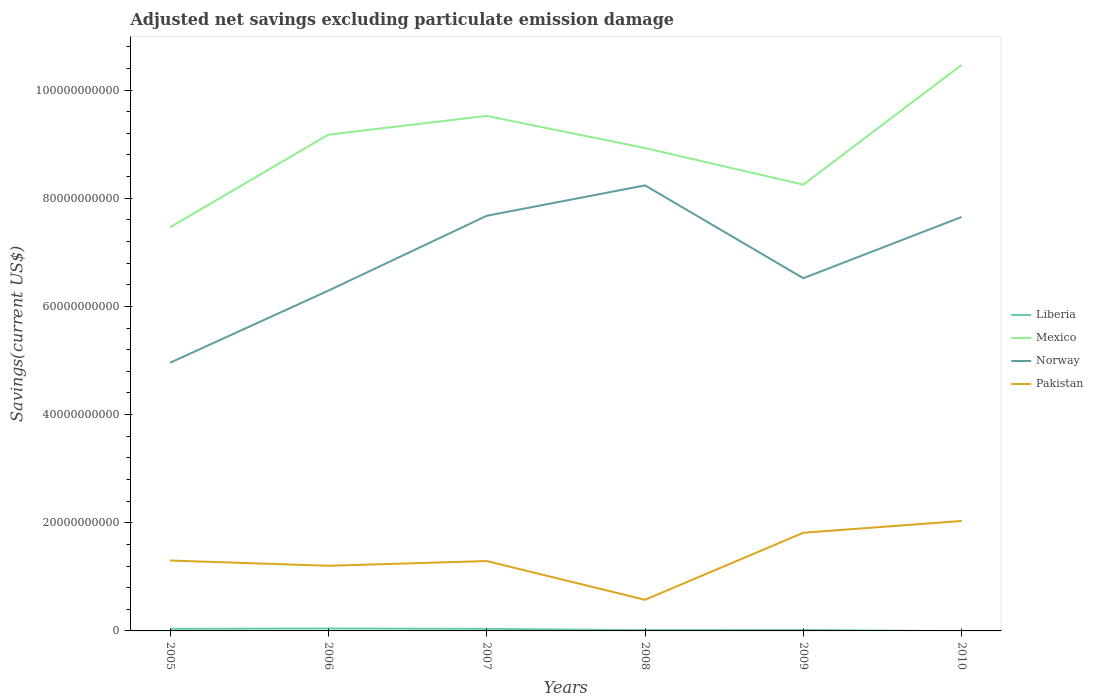Is the number of lines equal to the number of legend labels?
Your answer should be very brief. No. Across all years, what is the maximum adjusted net savings in Mexico?
Your response must be concise. 7.46e+1. What is the total adjusted net savings in Pakistan in the graph?
Make the answer very short. 9.67e+08. What is the difference between the highest and the second highest adjusted net savings in Pakistan?
Give a very brief answer. 1.46e+1. What is the difference between the highest and the lowest adjusted net savings in Mexico?
Ensure brevity in your answer.  3. How many lines are there?
Offer a very short reply. 4. What is the difference between two consecutive major ticks on the Y-axis?
Offer a very short reply. 2.00e+1. Does the graph contain any zero values?
Give a very brief answer. Yes. Where does the legend appear in the graph?
Give a very brief answer. Center right. How many legend labels are there?
Make the answer very short. 4. What is the title of the graph?
Keep it short and to the point. Adjusted net savings excluding particulate emission damage. Does "North America" appear as one of the legend labels in the graph?
Provide a succinct answer. No. What is the label or title of the X-axis?
Offer a very short reply. Years. What is the label or title of the Y-axis?
Ensure brevity in your answer.  Savings(current US$). What is the Savings(current US$) in Liberia in 2005?
Your answer should be very brief. 3.83e+08. What is the Savings(current US$) in Mexico in 2005?
Offer a very short reply. 7.46e+1. What is the Savings(current US$) in Norway in 2005?
Give a very brief answer. 4.96e+1. What is the Savings(current US$) of Pakistan in 2005?
Your answer should be compact. 1.30e+1. What is the Savings(current US$) in Liberia in 2006?
Provide a succinct answer. 4.46e+08. What is the Savings(current US$) of Mexico in 2006?
Provide a short and direct response. 9.18e+1. What is the Savings(current US$) of Norway in 2006?
Make the answer very short. 6.29e+1. What is the Savings(current US$) of Pakistan in 2006?
Your response must be concise. 1.20e+1. What is the Savings(current US$) of Liberia in 2007?
Offer a terse response. 3.82e+08. What is the Savings(current US$) of Mexico in 2007?
Keep it short and to the point. 9.52e+1. What is the Savings(current US$) of Norway in 2007?
Your answer should be very brief. 7.67e+1. What is the Savings(current US$) in Pakistan in 2007?
Make the answer very short. 1.29e+1. What is the Savings(current US$) in Liberia in 2008?
Offer a very short reply. 1.32e+08. What is the Savings(current US$) in Mexico in 2008?
Provide a short and direct response. 8.93e+1. What is the Savings(current US$) in Norway in 2008?
Ensure brevity in your answer.  8.24e+1. What is the Savings(current US$) in Pakistan in 2008?
Your answer should be very brief. 5.76e+09. What is the Savings(current US$) in Liberia in 2009?
Ensure brevity in your answer.  1.63e+08. What is the Savings(current US$) in Mexico in 2009?
Your answer should be very brief. 8.25e+1. What is the Savings(current US$) in Norway in 2009?
Provide a short and direct response. 6.52e+1. What is the Savings(current US$) in Pakistan in 2009?
Your response must be concise. 1.82e+1. What is the Savings(current US$) in Mexico in 2010?
Make the answer very short. 1.05e+11. What is the Savings(current US$) of Norway in 2010?
Your response must be concise. 7.65e+1. What is the Savings(current US$) in Pakistan in 2010?
Provide a succinct answer. 2.03e+1. Across all years, what is the maximum Savings(current US$) of Liberia?
Offer a terse response. 4.46e+08. Across all years, what is the maximum Savings(current US$) of Mexico?
Give a very brief answer. 1.05e+11. Across all years, what is the maximum Savings(current US$) of Norway?
Your response must be concise. 8.24e+1. Across all years, what is the maximum Savings(current US$) of Pakistan?
Ensure brevity in your answer.  2.03e+1. Across all years, what is the minimum Savings(current US$) of Mexico?
Give a very brief answer. 7.46e+1. Across all years, what is the minimum Savings(current US$) in Norway?
Your response must be concise. 4.96e+1. Across all years, what is the minimum Savings(current US$) in Pakistan?
Your response must be concise. 5.76e+09. What is the total Savings(current US$) of Liberia in the graph?
Keep it short and to the point. 1.51e+09. What is the total Savings(current US$) of Mexico in the graph?
Ensure brevity in your answer.  5.38e+11. What is the total Savings(current US$) in Norway in the graph?
Provide a succinct answer. 4.13e+11. What is the total Savings(current US$) of Pakistan in the graph?
Your answer should be compact. 8.22e+1. What is the difference between the Savings(current US$) in Liberia in 2005 and that in 2006?
Offer a terse response. -6.31e+07. What is the difference between the Savings(current US$) in Mexico in 2005 and that in 2006?
Keep it short and to the point. -1.71e+1. What is the difference between the Savings(current US$) in Norway in 2005 and that in 2006?
Make the answer very short. -1.33e+1. What is the difference between the Savings(current US$) of Pakistan in 2005 and that in 2006?
Make the answer very short. 9.67e+08. What is the difference between the Savings(current US$) in Liberia in 2005 and that in 2007?
Your answer should be compact. 1.06e+06. What is the difference between the Savings(current US$) of Mexico in 2005 and that in 2007?
Keep it short and to the point. -2.06e+1. What is the difference between the Savings(current US$) of Norway in 2005 and that in 2007?
Provide a succinct answer. -2.72e+1. What is the difference between the Savings(current US$) in Pakistan in 2005 and that in 2007?
Provide a short and direct response. 9.93e+07. What is the difference between the Savings(current US$) of Liberia in 2005 and that in 2008?
Keep it short and to the point. 2.51e+08. What is the difference between the Savings(current US$) of Mexico in 2005 and that in 2008?
Give a very brief answer. -1.46e+1. What is the difference between the Savings(current US$) in Norway in 2005 and that in 2008?
Your answer should be very brief. -3.28e+1. What is the difference between the Savings(current US$) in Pakistan in 2005 and that in 2008?
Your answer should be compact. 7.26e+09. What is the difference between the Savings(current US$) of Liberia in 2005 and that in 2009?
Provide a succinct answer. 2.20e+08. What is the difference between the Savings(current US$) of Mexico in 2005 and that in 2009?
Make the answer very short. -7.88e+09. What is the difference between the Savings(current US$) in Norway in 2005 and that in 2009?
Your response must be concise. -1.56e+1. What is the difference between the Savings(current US$) in Pakistan in 2005 and that in 2009?
Keep it short and to the point. -5.14e+09. What is the difference between the Savings(current US$) in Mexico in 2005 and that in 2010?
Offer a terse response. -3.00e+1. What is the difference between the Savings(current US$) in Norway in 2005 and that in 2010?
Give a very brief answer. -2.69e+1. What is the difference between the Savings(current US$) in Pakistan in 2005 and that in 2010?
Keep it short and to the point. -7.31e+09. What is the difference between the Savings(current US$) of Liberia in 2006 and that in 2007?
Keep it short and to the point. 6.42e+07. What is the difference between the Savings(current US$) of Mexico in 2006 and that in 2007?
Offer a terse response. -3.46e+09. What is the difference between the Savings(current US$) in Norway in 2006 and that in 2007?
Offer a terse response. -1.38e+1. What is the difference between the Savings(current US$) of Pakistan in 2006 and that in 2007?
Give a very brief answer. -8.68e+08. What is the difference between the Savings(current US$) in Liberia in 2006 and that in 2008?
Provide a short and direct response. 3.15e+08. What is the difference between the Savings(current US$) in Mexico in 2006 and that in 2008?
Make the answer very short. 2.48e+09. What is the difference between the Savings(current US$) of Norway in 2006 and that in 2008?
Provide a succinct answer. -1.95e+1. What is the difference between the Savings(current US$) in Pakistan in 2006 and that in 2008?
Provide a short and direct response. 6.29e+09. What is the difference between the Savings(current US$) of Liberia in 2006 and that in 2009?
Your answer should be compact. 2.84e+08. What is the difference between the Savings(current US$) of Mexico in 2006 and that in 2009?
Offer a terse response. 9.25e+09. What is the difference between the Savings(current US$) of Norway in 2006 and that in 2009?
Your response must be concise. -2.30e+09. What is the difference between the Savings(current US$) in Pakistan in 2006 and that in 2009?
Make the answer very short. -6.10e+09. What is the difference between the Savings(current US$) in Mexico in 2006 and that in 2010?
Make the answer very short. -1.29e+1. What is the difference between the Savings(current US$) in Norway in 2006 and that in 2010?
Keep it short and to the point. -1.36e+1. What is the difference between the Savings(current US$) in Pakistan in 2006 and that in 2010?
Your response must be concise. -8.28e+09. What is the difference between the Savings(current US$) of Liberia in 2007 and that in 2008?
Offer a very short reply. 2.50e+08. What is the difference between the Savings(current US$) in Mexico in 2007 and that in 2008?
Offer a terse response. 5.94e+09. What is the difference between the Savings(current US$) of Norway in 2007 and that in 2008?
Ensure brevity in your answer.  -5.62e+09. What is the difference between the Savings(current US$) in Pakistan in 2007 and that in 2008?
Your answer should be very brief. 7.16e+09. What is the difference between the Savings(current US$) in Liberia in 2007 and that in 2009?
Offer a terse response. 2.19e+08. What is the difference between the Savings(current US$) in Mexico in 2007 and that in 2009?
Your answer should be compact. 1.27e+1. What is the difference between the Savings(current US$) in Norway in 2007 and that in 2009?
Make the answer very short. 1.15e+1. What is the difference between the Savings(current US$) in Pakistan in 2007 and that in 2009?
Your response must be concise. -5.24e+09. What is the difference between the Savings(current US$) of Mexico in 2007 and that in 2010?
Provide a short and direct response. -9.44e+09. What is the difference between the Savings(current US$) in Norway in 2007 and that in 2010?
Keep it short and to the point. 2.15e+08. What is the difference between the Savings(current US$) of Pakistan in 2007 and that in 2010?
Make the answer very short. -7.41e+09. What is the difference between the Savings(current US$) of Liberia in 2008 and that in 2009?
Make the answer very short. -3.10e+07. What is the difference between the Savings(current US$) in Mexico in 2008 and that in 2009?
Keep it short and to the point. 6.77e+09. What is the difference between the Savings(current US$) in Norway in 2008 and that in 2009?
Keep it short and to the point. 1.72e+1. What is the difference between the Savings(current US$) in Pakistan in 2008 and that in 2009?
Your answer should be compact. -1.24e+1. What is the difference between the Savings(current US$) of Mexico in 2008 and that in 2010?
Give a very brief answer. -1.54e+1. What is the difference between the Savings(current US$) of Norway in 2008 and that in 2010?
Give a very brief answer. 5.84e+09. What is the difference between the Savings(current US$) of Pakistan in 2008 and that in 2010?
Offer a terse response. -1.46e+1. What is the difference between the Savings(current US$) of Mexico in 2009 and that in 2010?
Keep it short and to the point. -2.21e+1. What is the difference between the Savings(current US$) of Norway in 2009 and that in 2010?
Your answer should be very brief. -1.13e+1. What is the difference between the Savings(current US$) of Pakistan in 2009 and that in 2010?
Offer a terse response. -2.18e+09. What is the difference between the Savings(current US$) of Liberia in 2005 and the Savings(current US$) of Mexico in 2006?
Your response must be concise. -9.14e+1. What is the difference between the Savings(current US$) of Liberia in 2005 and the Savings(current US$) of Norway in 2006?
Offer a very short reply. -6.25e+1. What is the difference between the Savings(current US$) of Liberia in 2005 and the Savings(current US$) of Pakistan in 2006?
Make the answer very short. -1.17e+1. What is the difference between the Savings(current US$) in Mexico in 2005 and the Savings(current US$) in Norway in 2006?
Make the answer very short. 1.17e+1. What is the difference between the Savings(current US$) in Mexico in 2005 and the Savings(current US$) in Pakistan in 2006?
Your response must be concise. 6.26e+1. What is the difference between the Savings(current US$) in Norway in 2005 and the Savings(current US$) in Pakistan in 2006?
Offer a terse response. 3.75e+1. What is the difference between the Savings(current US$) of Liberia in 2005 and the Savings(current US$) of Mexico in 2007?
Keep it short and to the point. -9.48e+1. What is the difference between the Savings(current US$) of Liberia in 2005 and the Savings(current US$) of Norway in 2007?
Give a very brief answer. -7.64e+1. What is the difference between the Savings(current US$) of Liberia in 2005 and the Savings(current US$) of Pakistan in 2007?
Give a very brief answer. -1.25e+1. What is the difference between the Savings(current US$) of Mexico in 2005 and the Savings(current US$) of Norway in 2007?
Ensure brevity in your answer.  -2.12e+09. What is the difference between the Savings(current US$) of Mexico in 2005 and the Savings(current US$) of Pakistan in 2007?
Offer a terse response. 6.17e+1. What is the difference between the Savings(current US$) of Norway in 2005 and the Savings(current US$) of Pakistan in 2007?
Your answer should be compact. 3.67e+1. What is the difference between the Savings(current US$) in Liberia in 2005 and the Savings(current US$) in Mexico in 2008?
Your answer should be compact. -8.89e+1. What is the difference between the Savings(current US$) of Liberia in 2005 and the Savings(current US$) of Norway in 2008?
Make the answer very short. -8.20e+1. What is the difference between the Savings(current US$) in Liberia in 2005 and the Savings(current US$) in Pakistan in 2008?
Your response must be concise. -5.37e+09. What is the difference between the Savings(current US$) of Mexico in 2005 and the Savings(current US$) of Norway in 2008?
Offer a terse response. -7.74e+09. What is the difference between the Savings(current US$) in Mexico in 2005 and the Savings(current US$) in Pakistan in 2008?
Keep it short and to the point. 6.89e+1. What is the difference between the Savings(current US$) of Norway in 2005 and the Savings(current US$) of Pakistan in 2008?
Offer a terse response. 4.38e+1. What is the difference between the Savings(current US$) of Liberia in 2005 and the Savings(current US$) of Mexico in 2009?
Offer a very short reply. -8.21e+1. What is the difference between the Savings(current US$) of Liberia in 2005 and the Savings(current US$) of Norway in 2009?
Your answer should be compact. -6.48e+1. What is the difference between the Savings(current US$) in Liberia in 2005 and the Savings(current US$) in Pakistan in 2009?
Offer a very short reply. -1.78e+1. What is the difference between the Savings(current US$) of Mexico in 2005 and the Savings(current US$) of Norway in 2009?
Give a very brief answer. 9.42e+09. What is the difference between the Savings(current US$) in Mexico in 2005 and the Savings(current US$) in Pakistan in 2009?
Your answer should be compact. 5.65e+1. What is the difference between the Savings(current US$) in Norway in 2005 and the Savings(current US$) in Pakistan in 2009?
Make the answer very short. 3.14e+1. What is the difference between the Savings(current US$) in Liberia in 2005 and the Savings(current US$) in Mexico in 2010?
Give a very brief answer. -1.04e+11. What is the difference between the Savings(current US$) in Liberia in 2005 and the Savings(current US$) in Norway in 2010?
Your response must be concise. -7.62e+1. What is the difference between the Savings(current US$) in Liberia in 2005 and the Savings(current US$) in Pakistan in 2010?
Ensure brevity in your answer.  -1.99e+1. What is the difference between the Savings(current US$) of Mexico in 2005 and the Savings(current US$) of Norway in 2010?
Offer a very short reply. -1.91e+09. What is the difference between the Savings(current US$) in Mexico in 2005 and the Savings(current US$) in Pakistan in 2010?
Your answer should be very brief. 5.43e+1. What is the difference between the Savings(current US$) in Norway in 2005 and the Savings(current US$) in Pakistan in 2010?
Provide a succinct answer. 2.93e+1. What is the difference between the Savings(current US$) in Liberia in 2006 and the Savings(current US$) in Mexico in 2007?
Your answer should be very brief. -9.48e+1. What is the difference between the Savings(current US$) in Liberia in 2006 and the Savings(current US$) in Norway in 2007?
Give a very brief answer. -7.63e+1. What is the difference between the Savings(current US$) in Liberia in 2006 and the Savings(current US$) in Pakistan in 2007?
Keep it short and to the point. -1.25e+1. What is the difference between the Savings(current US$) in Mexico in 2006 and the Savings(current US$) in Norway in 2007?
Give a very brief answer. 1.50e+1. What is the difference between the Savings(current US$) of Mexico in 2006 and the Savings(current US$) of Pakistan in 2007?
Provide a succinct answer. 7.88e+1. What is the difference between the Savings(current US$) in Norway in 2006 and the Savings(current US$) in Pakistan in 2007?
Offer a terse response. 5.00e+1. What is the difference between the Savings(current US$) in Liberia in 2006 and the Savings(current US$) in Mexico in 2008?
Provide a short and direct response. -8.88e+1. What is the difference between the Savings(current US$) in Liberia in 2006 and the Savings(current US$) in Norway in 2008?
Ensure brevity in your answer.  -8.19e+1. What is the difference between the Savings(current US$) of Liberia in 2006 and the Savings(current US$) of Pakistan in 2008?
Your answer should be very brief. -5.31e+09. What is the difference between the Savings(current US$) of Mexico in 2006 and the Savings(current US$) of Norway in 2008?
Give a very brief answer. 9.38e+09. What is the difference between the Savings(current US$) of Mexico in 2006 and the Savings(current US$) of Pakistan in 2008?
Your answer should be very brief. 8.60e+1. What is the difference between the Savings(current US$) in Norway in 2006 and the Savings(current US$) in Pakistan in 2008?
Your answer should be very brief. 5.72e+1. What is the difference between the Savings(current US$) of Liberia in 2006 and the Savings(current US$) of Mexico in 2009?
Offer a terse response. -8.21e+1. What is the difference between the Savings(current US$) of Liberia in 2006 and the Savings(current US$) of Norway in 2009?
Give a very brief answer. -6.48e+1. What is the difference between the Savings(current US$) of Liberia in 2006 and the Savings(current US$) of Pakistan in 2009?
Offer a very short reply. -1.77e+1. What is the difference between the Savings(current US$) of Mexico in 2006 and the Savings(current US$) of Norway in 2009?
Provide a short and direct response. 2.65e+1. What is the difference between the Savings(current US$) of Mexico in 2006 and the Savings(current US$) of Pakistan in 2009?
Your answer should be compact. 7.36e+1. What is the difference between the Savings(current US$) of Norway in 2006 and the Savings(current US$) of Pakistan in 2009?
Offer a very short reply. 4.48e+1. What is the difference between the Savings(current US$) in Liberia in 2006 and the Savings(current US$) in Mexico in 2010?
Provide a succinct answer. -1.04e+11. What is the difference between the Savings(current US$) in Liberia in 2006 and the Savings(current US$) in Norway in 2010?
Your response must be concise. -7.61e+1. What is the difference between the Savings(current US$) in Liberia in 2006 and the Savings(current US$) in Pakistan in 2010?
Offer a very short reply. -1.99e+1. What is the difference between the Savings(current US$) of Mexico in 2006 and the Savings(current US$) of Norway in 2010?
Provide a succinct answer. 1.52e+1. What is the difference between the Savings(current US$) in Mexico in 2006 and the Savings(current US$) in Pakistan in 2010?
Provide a succinct answer. 7.14e+1. What is the difference between the Savings(current US$) in Norway in 2006 and the Savings(current US$) in Pakistan in 2010?
Provide a succinct answer. 4.26e+1. What is the difference between the Savings(current US$) in Liberia in 2007 and the Savings(current US$) in Mexico in 2008?
Provide a short and direct response. -8.89e+1. What is the difference between the Savings(current US$) in Liberia in 2007 and the Savings(current US$) in Norway in 2008?
Keep it short and to the point. -8.20e+1. What is the difference between the Savings(current US$) of Liberia in 2007 and the Savings(current US$) of Pakistan in 2008?
Your response must be concise. -5.37e+09. What is the difference between the Savings(current US$) in Mexico in 2007 and the Savings(current US$) in Norway in 2008?
Your answer should be very brief. 1.28e+1. What is the difference between the Savings(current US$) of Mexico in 2007 and the Savings(current US$) of Pakistan in 2008?
Make the answer very short. 8.95e+1. What is the difference between the Savings(current US$) of Norway in 2007 and the Savings(current US$) of Pakistan in 2008?
Give a very brief answer. 7.10e+1. What is the difference between the Savings(current US$) of Liberia in 2007 and the Savings(current US$) of Mexico in 2009?
Provide a succinct answer. -8.21e+1. What is the difference between the Savings(current US$) in Liberia in 2007 and the Savings(current US$) in Norway in 2009?
Give a very brief answer. -6.48e+1. What is the difference between the Savings(current US$) of Liberia in 2007 and the Savings(current US$) of Pakistan in 2009?
Your response must be concise. -1.78e+1. What is the difference between the Savings(current US$) of Mexico in 2007 and the Savings(current US$) of Norway in 2009?
Offer a very short reply. 3.00e+1. What is the difference between the Savings(current US$) of Mexico in 2007 and the Savings(current US$) of Pakistan in 2009?
Your response must be concise. 7.71e+1. What is the difference between the Savings(current US$) of Norway in 2007 and the Savings(current US$) of Pakistan in 2009?
Keep it short and to the point. 5.86e+1. What is the difference between the Savings(current US$) in Liberia in 2007 and the Savings(current US$) in Mexico in 2010?
Keep it short and to the point. -1.04e+11. What is the difference between the Savings(current US$) of Liberia in 2007 and the Savings(current US$) of Norway in 2010?
Make the answer very short. -7.62e+1. What is the difference between the Savings(current US$) of Liberia in 2007 and the Savings(current US$) of Pakistan in 2010?
Your response must be concise. -1.99e+1. What is the difference between the Savings(current US$) in Mexico in 2007 and the Savings(current US$) in Norway in 2010?
Your response must be concise. 1.87e+1. What is the difference between the Savings(current US$) of Mexico in 2007 and the Savings(current US$) of Pakistan in 2010?
Your answer should be very brief. 7.49e+1. What is the difference between the Savings(current US$) in Norway in 2007 and the Savings(current US$) in Pakistan in 2010?
Give a very brief answer. 5.64e+1. What is the difference between the Savings(current US$) of Liberia in 2008 and the Savings(current US$) of Mexico in 2009?
Your answer should be compact. -8.24e+1. What is the difference between the Savings(current US$) of Liberia in 2008 and the Savings(current US$) of Norway in 2009?
Make the answer very short. -6.51e+1. What is the difference between the Savings(current US$) of Liberia in 2008 and the Savings(current US$) of Pakistan in 2009?
Your answer should be very brief. -1.80e+1. What is the difference between the Savings(current US$) in Mexico in 2008 and the Savings(current US$) in Norway in 2009?
Offer a terse response. 2.41e+1. What is the difference between the Savings(current US$) of Mexico in 2008 and the Savings(current US$) of Pakistan in 2009?
Offer a very short reply. 7.11e+1. What is the difference between the Savings(current US$) in Norway in 2008 and the Savings(current US$) in Pakistan in 2009?
Provide a succinct answer. 6.42e+1. What is the difference between the Savings(current US$) in Liberia in 2008 and the Savings(current US$) in Mexico in 2010?
Provide a succinct answer. -1.05e+11. What is the difference between the Savings(current US$) in Liberia in 2008 and the Savings(current US$) in Norway in 2010?
Provide a succinct answer. -7.64e+1. What is the difference between the Savings(current US$) in Liberia in 2008 and the Savings(current US$) in Pakistan in 2010?
Ensure brevity in your answer.  -2.02e+1. What is the difference between the Savings(current US$) in Mexico in 2008 and the Savings(current US$) in Norway in 2010?
Make the answer very short. 1.27e+1. What is the difference between the Savings(current US$) in Mexico in 2008 and the Savings(current US$) in Pakistan in 2010?
Provide a succinct answer. 6.90e+1. What is the difference between the Savings(current US$) of Norway in 2008 and the Savings(current US$) of Pakistan in 2010?
Your answer should be very brief. 6.20e+1. What is the difference between the Savings(current US$) in Liberia in 2009 and the Savings(current US$) in Mexico in 2010?
Ensure brevity in your answer.  -1.04e+11. What is the difference between the Savings(current US$) in Liberia in 2009 and the Savings(current US$) in Norway in 2010?
Offer a terse response. -7.64e+1. What is the difference between the Savings(current US$) of Liberia in 2009 and the Savings(current US$) of Pakistan in 2010?
Your response must be concise. -2.02e+1. What is the difference between the Savings(current US$) in Mexico in 2009 and the Savings(current US$) in Norway in 2010?
Offer a terse response. 5.97e+09. What is the difference between the Savings(current US$) of Mexico in 2009 and the Savings(current US$) of Pakistan in 2010?
Your answer should be very brief. 6.22e+1. What is the difference between the Savings(current US$) of Norway in 2009 and the Savings(current US$) of Pakistan in 2010?
Give a very brief answer. 4.49e+1. What is the average Savings(current US$) of Liberia per year?
Offer a terse response. 2.51e+08. What is the average Savings(current US$) in Mexico per year?
Offer a very short reply. 8.97e+1. What is the average Savings(current US$) of Norway per year?
Offer a very short reply. 6.89e+1. What is the average Savings(current US$) in Pakistan per year?
Your answer should be compact. 1.37e+1. In the year 2005, what is the difference between the Savings(current US$) in Liberia and Savings(current US$) in Mexico?
Offer a very short reply. -7.42e+1. In the year 2005, what is the difference between the Savings(current US$) of Liberia and Savings(current US$) of Norway?
Your answer should be very brief. -4.92e+1. In the year 2005, what is the difference between the Savings(current US$) of Liberia and Savings(current US$) of Pakistan?
Offer a terse response. -1.26e+1. In the year 2005, what is the difference between the Savings(current US$) in Mexico and Savings(current US$) in Norway?
Your response must be concise. 2.50e+1. In the year 2005, what is the difference between the Savings(current US$) in Mexico and Savings(current US$) in Pakistan?
Give a very brief answer. 6.16e+1. In the year 2005, what is the difference between the Savings(current US$) of Norway and Savings(current US$) of Pakistan?
Your answer should be compact. 3.66e+1. In the year 2006, what is the difference between the Savings(current US$) of Liberia and Savings(current US$) of Mexico?
Keep it short and to the point. -9.13e+1. In the year 2006, what is the difference between the Savings(current US$) of Liberia and Savings(current US$) of Norway?
Your response must be concise. -6.25e+1. In the year 2006, what is the difference between the Savings(current US$) of Liberia and Savings(current US$) of Pakistan?
Offer a terse response. -1.16e+1. In the year 2006, what is the difference between the Savings(current US$) in Mexico and Savings(current US$) in Norway?
Give a very brief answer. 2.88e+1. In the year 2006, what is the difference between the Savings(current US$) in Mexico and Savings(current US$) in Pakistan?
Keep it short and to the point. 7.97e+1. In the year 2006, what is the difference between the Savings(current US$) of Norway and Savings(current US$) of Pakistan?
Ensure brevity in your answer.  5.09e+1. In the year 2007, what is the difference between the Savings(current US$) in Liberia and Savings(current US$) in Mexico?
Offer a terse response. -9.48e+1. In the year 2007, what is the difference between the Savings(current US$) in Liberia and Savings(current US$) in Norway?
Offer a terse response. -7.64e+1. In the year 2007, what is the difference between the Savings(current US$) of Liberia and Savings(current US$) of Pakistan?
Your answer should be compact. -1.25e+1. In the year 2007, what is the difference between the Savings(current US$) in Mexico and Savings(current US$) in Norway?
Keep it short and to the point. 1.85e+1. In the year 2007, what is the difference between the Savings(current US$) of Mexico and Savings(current US$) of Pakistan?
Offer a terse response. 8.23e+1. In the year 2007, what is the difference between the Savings(current US$) in Norway and Savings(current US$) in Pakistan?
Keep it short and to the point. 6.38e+1. In the year 2008, what is the difference between the Savings(current US$) of Liberia and Savings(current US$) of Mexico?
Give a very brief answer. -8.91e+1. In the year 2008, what is the difference between the Savings(current US$) of Liberia and Savings(current US$) of Norway?
Ensure brevity in your answer.  -8.22e+1. In the year 2008, what is the difference between the Savings(current US$) of Liberia and Savings(current US$) of Pakistan?
Provide a succinct answer. -5.62e+09. In the year 2008, what is the difference between the Savings(current US$) of Mexico and Savings(current US$) of Norway?
Provide a short and direct response. 6.90e+09. In the year 2008, what is the difference between the Savings(current US$) in Mexico and Savings(current US$) in Pakistan?
Provide a succinct answer. 8.35e+1. In the year 2008, what is the difference between the Savings(current US$) in Norway and Savings(current US$) in Pakistan?
Make the answer very short. 7.66e+1. In the year 2009, what is the difference between the Savings(current US$) of Liberia and Savings(current US$) of Mexico?
Give a very brief answer. -8.23e+1. In the year 2009, what is the difference between the Savings(current US$) of Liberia and Savings(current US$) of Norway?
Keep it short and to the point. -6.50e+1. In the year 2009, what is the difference between the Savings(current US$) of Liberia and Savings(current US$) of Pakistan?
Ensure brevity in your answer.  -1.80e+1. In the year 2009, what is the difference between the Savings(current US$) of Mexico and Savings(current US$) of Norway?
Offer a very short reply. 1.73e+1. In the year 2009, what is the difference between the Savings(current US$) in Mexico and Savings(current US$) in Pakistan?
Give a very brief answer. 6.44e+1. In the year 2009, what is the difference between the Savings(current US$) in Norway and Savings(current US$) in Pakistan?
Offer a very short reply. 4.71e+1. In the year 2010, what is the difference between the Savings(current US$) of Mexico and Savings(current US$) of Norway?
Provide a short and direct response. 2.81e+1. In the year 2010, what is the difference between the Savings(current US$) in Mexico and Savings(current US$) in Pakistan?
Your response must be concise. 8.43e+1. In the year 2010, what is the difference between the Savings(current US$) in Norway and Savings(current US$) in Pakistan?
Provide a succinct answer. 5.62e+1. What is the ratio of the Savings(current US$) in Liberia in 2005 to that in 2006?
Make the answer very short. 0.86. What is the ratio of the Savings(current US$) of Mexico in 2005 to that in 2006?
Give a very brief answer. 0.81. What is the ratio of the Savings(current US$) in Norway in 2005 to that in 2006?
Provide a short and direct response. 0.79. What is the ratio of the Savings(current US$) of Pakistan in 2005 to that in 2006?
Make the answer very short. 1.08. What is the ratio of the Savings(current US$) of Liberia in 2005 to that in 2007?
Provide a succinct answer. 1. What is the ratio of the Savings(current US$) of Mexico in 2005 to that in 2007?
Offer a very short reply. 0.78. What is the ratio of the Savings(current US$) in Norway in 2005 to that in 2007?
Give a very brief answer. 0.65. What is the ratio of the Savings(current US$) in Pakistan in 2005 to that in 2007?
Your response must be concise. 1.01. What is the ratio of the Savings(current US$) of Liberia in 2005 to that in 2008?
Your response must be concise. 2.91. What is the ratio of the Savings(current US$) of Mexico in 2005 to that in 2008?
Make the answer very short. 0.84. What is the ratio of the Savings(current US$) in Norway in 2005 to that in 2008?
Offer a very short reply. 0.6. What is the ratio of the Savings(current US$) of Pakistan in 2005 to that in 2008?
Give a very brief answer. 2.26. What is the ratio of the Savings(current US$) in Liberia in 2005 to that in 2009?
Offer a terse response. 2.35. What is the ratio of the Savings(current US$) of Mexico in 2005 to that in 2009?
Provide a short and direct response. 0.9. What is the ratio of the Savings(current US$) of Norway in 2005 to that in 2009?
Offer a very short reply. 0.76. What is the ratio of the Savings(current US$) of Pakistan in 2005 to that in 2009?
Provide a succinct answer. 0.72. What is the ratio of the Savings(current US$) in Mexico in 2005 to that in 2010?
Offer a very short reply. 0.71. What is the ratio of the Savings(current US$) of Norway in 2005 to that in 2010?
Your answer should be very brief. 0.65. What is the ratio of the Savings(current US$) in Pakistan in 2005 to that in 2010?
Offer a very short reply. 0.64. What is the ratio of the Savings(current US$) of Liberia in 2006 to that in 2007?
Your response must be concise. 1.17. What is the ratio of the Savings(current US$) in Mexico in 2006 to that in 2007?
Provide a short and direct response. 0.96. What is the ratio of the Savings(current US$) in Norway in 2006 to that in 2007?
Give a very brief answer. 0.82. What is the ratio of the Savings(current US$) in Pakistan in 2006 to that in 2007?
Provide a succinct answer. 0.93. What is the ratio of the Savings(current US$) in Liberia in 2006 to that in 2008?
Give a very brief answer. 3.38. What is the ratio of the Savings(current US$) in Mexico in 2006 to that in 2008?
Your response must be concise. 1.03. What is the ratio of the Savings(current US$) in Norway in 2006 to that in 2008?
Your response must be concise. 0.76. What is the ratio of the Savings(current US$) of Pakistan in 2006 to that in 2008?
Give a very brief answer. 2.09. What is the ratio of the Savings(current US$) in Liberia in 2006 to that in 2009?
Offer a terse response. 2.74. What is the ratio of the Savings(current US$) in Mexico in 2006 to that in 2009?
Keep it short and to the point. 1.11. What is the ratio of the Savings(current US$) in Norway in 2006 to that in 2009?
Give a very brief answer. 0.96. What is the ratio of the Savings(current US$) in Pakistan in 2006 to that in 2009?
Provide a succinct answer. 0.66. What is the ratio of the Savings(current US$) in Mexico in 2006 to that in 2010?
Your answer should be very brief. 0.88. What is the ratio of the Savings(current US$) of Norway in 2006 to that in 2010?
Keep it short and to the point. 0.82. What is the ratio of the Savings(current US$) in Pakistan in 2006 to that in 2010?
Make the answer very short. 0.59. What is the ratio of the Savings(current US$) in Liberia in 2007 to that in 2008?
Offer a very short reply. 2.9. What is the ratio of the Savings(current US$) in Mexico in 2007 to that in 2008?
Your answer should be compact. 1.07. What is the ratio of the Savings(current US$) of Norway in 2007 to that in 2008?
Give a very brief answer. 0.93. What is the ratio of the Savings(current US$) of Pakistan in 2007 to that in 2008?
Your answer should be compact. 2.24. What is the ratio of the Savings(current US$) of Liberia in 2007 to that in 2009?
Offer a very short reply. 2.35. What is the ratio of the Savings(current US$) of Mexico in 2007 to that in 2009?
Provide a short and direct response. 1.15. What is the ratio of the Savings(current US$) in Norway in 2007 to that in 2009?
Offer a very short reply. 1.18. What is the ratio of the Savings(current US$) of Pakistan in 2007 to that in 2009?
Give a very brief answer. 0.71. What is the ratio of the Savings(current US$) of Mexico in 2007 to that in 2010?
Ensure brevity in your answer.  0.91. What is the ratio of the Savings(current US$) of Pakistan in 2007 to that in 2010?
Keep it short and to the point. 0.64. What is the ratio of the Savings(current US$) of Liberia in 2008 to that in 2009?
Provide a short and direct response. 0.81. What is the ratio of the Savings(current US$) of Mexico in 2008 to that in 2009?
Offer a very short reply. 1.08. What is the ratio of the Savings(current US$) of Norway in 2008 to that in 2009?
Your answer should be compact. 1.26. What is the ratio of the Savings(current US$) of Pakistan in 2008 to that in 2009?
Ensure brevity in your answer.  0.32. What is the ratio of the Savings(current US$) of Mexico in 2008 to that in 2010?
Offer a very short reply. 0.85. What is the ratio of the Savings(current US$) of Norway in 2008 to that in 2010?
Make the answer very short. 1.08. What is the ratio of the Savings(current US$) in Pakistan in 2008 to that in 2010?
Provide a short and direct response. 0.28. What is the ratio of the Savings(current US$) of Mexico in 2009 to that in 2010?
Your response must be concise. 0.79. What is the ratio of the Savings(current US$) of Norway in 2009 to that in 2010?
Your answer should be compact. 0.85. What is the ratio of the Savings(current US$) of Pakistan in 2009 to that in 2010?
Make the answer very short. 0.89. What is the difference between the highest and the second highest Savings(current US$) of Liberia?
Make the answer very short. 6.31e+07. What is the difference between the highest and the second highest Savings(current US$) of Mexico?
Your answer should be compact. 9.44e+09. What is the difference between the highest and the second highest Savings(current US$) of Norway?
Provide a succinct answer. 5.62e+09. What is the difference between the highest and the second highest Savings(current US$) of Pakistan?
Make the answer very short. 2.18e+09. What is the difference between the highest and the lowest Savings(current US$) of Liberia?
Provide a short and direct response. 4.46e+08. What is the difference between the highest and the lowest Savings(current US$) of Mexico?
Give a very brief answer. 3.00e+1. What is the difference between the highest and the lowest Savings(current US$) in Norway?
Give a very brief answer. 3.28e+1. What is the difference between the highest and the lowest Savings(current US$) of Pakistan?
Make the answer very short. 1.46e+1. 